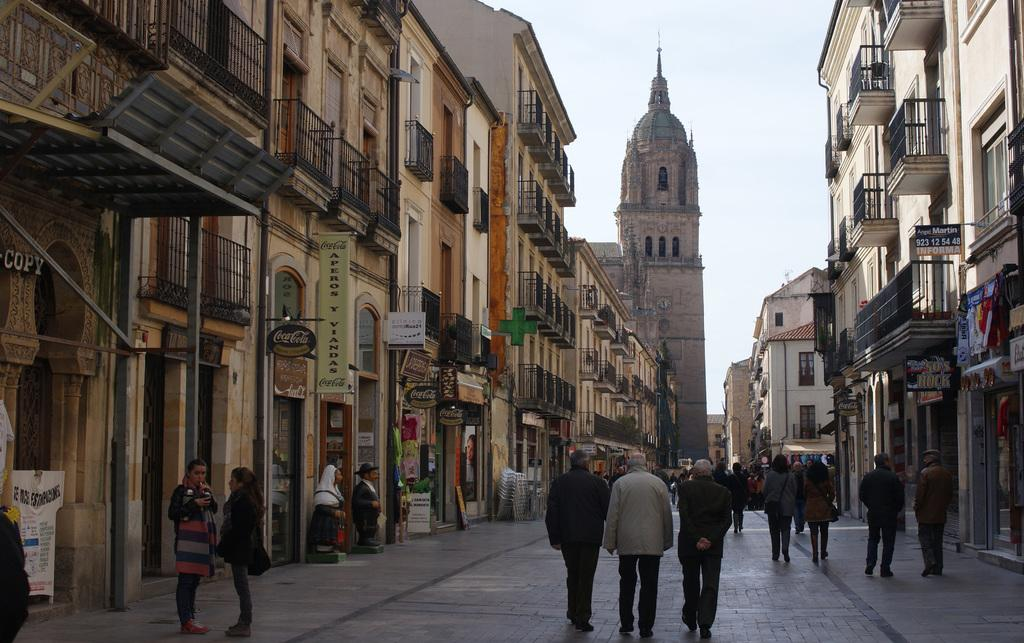What are the people in the image doing? The people in the image are walking. Where are the people walking? The people are walking on a path. What can be seen on either side of the path? There are buildings on either side of the path. What is visible in the background of the image? The sky is visible in the background of the image. What type of expansion is being requested by the alarm in the image? There is no alarm present in the image, so it is not possible to answer that question. 